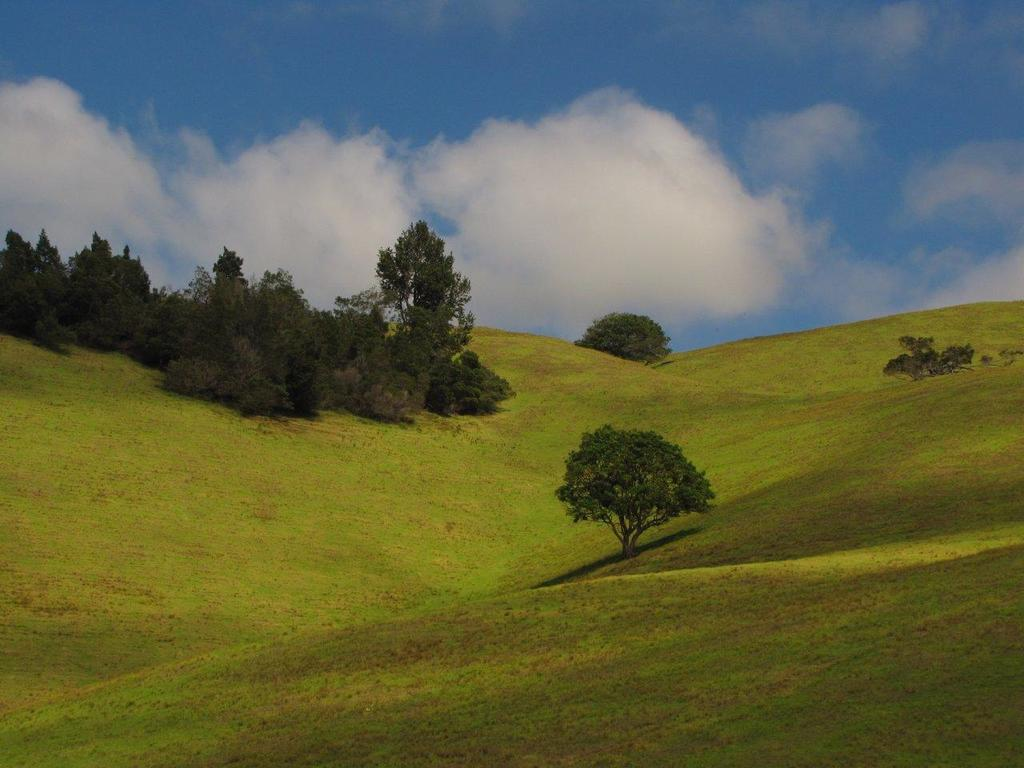What type of landscape is depicted in the image? The image features hills. What other natural elements can be seen in the image? There are trees in the image. What is visible in the background of the image? The sky is visible in the background of the image. What type of whistle can be heard in the image? There is no whistle present in the image, as it is a still image and does not contain any sounds. 